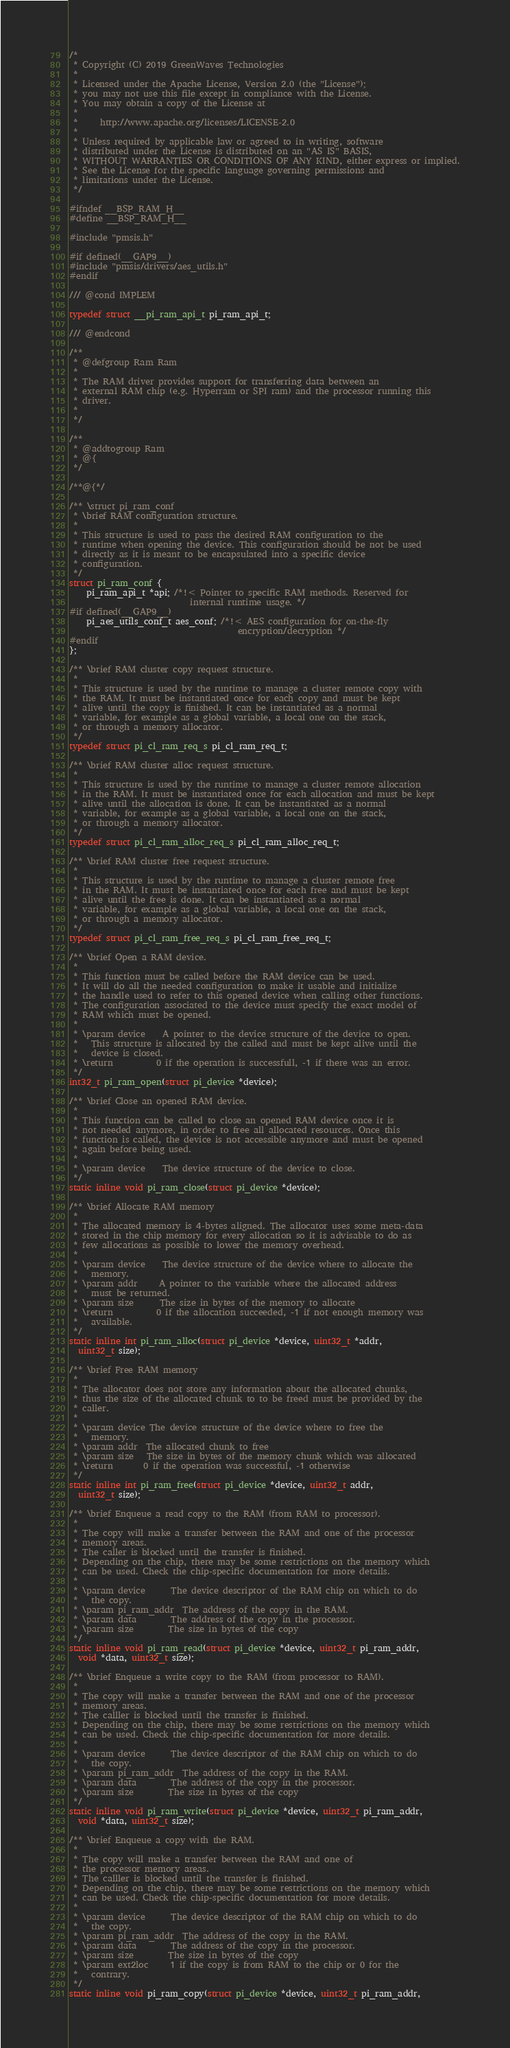<code> <loc_0><loc_0><loc_500><loc_500><_C_>/*
 * Copyright (C) 2019 GreenWaves Technologies
 *
 * Licensed under the Apache License, Version 2.0 (the "License");
 * you may not use this file except in compliance with the License.
 * You may obtain a copy of the License at
 *
 *     http://www.apache.org/licenses/LICENSE-2.0
 *
 * Unless required by applicable law or agreed to in writing, software
 * distributed under the License is distributed on an "AS IS" BASIS,
 * WITHOUT WARRANTIES OR CONDITIONS OF ANY KIND, either express or implied.
 * See the License for the specific language governing permissions and
 * limitations under the License.
 */

#ifndef __BSP_RAM_H__
#define __BSP_RAM_H__

#include "pmsis.h"

#if defined(__GAP9__)
#include "pmsis/drivers/aes_utils.h"
#endif

/// @cond IMPLEM

typedef struct __pi_ram_api_t pi_ram_api_t;

/// @endcond

/**
 * @defgroup Ram Ram
 *
 * The RAM driver provides support for transferring data between an
 * external RAM chip (e.g. Hyperram or SPI ram) and the processor running this
 * driver.
 *
 */

/**
 * @addtogroup Ram
 * @{
 */

/**@{*/

/** \struct pi_ram_conf
 * \brief RAM configuration structure.
 *
 * This structure is used to pass the desired RAM configuration to the
 * runtime when opening the device. This configuration should be not be used
 * directly as it is meant to be encapsulated into a specific device
 * configuration.
 */
struct pi_ram_conf {
    pi_ram_api_t *api; /*!< Pointer to specific RAM methods. Reserved for
                            internal runtime usage. */
#if defined(__GAP9__)
    pi_aes_utils_conf_t aes_conf; /*!< AES configuration for on-the-fly
                                       encryption/decryption */
#endif
};

/** \brief RAM cluster copy request structure.
 *
 * This structure is used by the runtime to manage a cluster remote copy with
 * the RAM. It must be instantiated once for each copy and must be kept
 * alive until the copy is finished. It can be instantiated as a normal
 * variable, for example as a global variable, a local one on the stack,
 * or through a memory allocator.
 */
typedef struct pi_cl_ram_req_s pi_cl_ram_req_t;

/** \brief RAM cluster alloc request structure.
 *
 * This structure is used by the runtime to manage a cluster remote allocation
 * in the RAM. It must be instantiated once for each allocation and must be kept
 * alive until the allocation is done. It can be instantiated as a normal
 * variable, for example as a global variable, a local one on the stack,
 * or through a memory allocator.
 */
typedef struct pi_cl_ram_alloc_req_s pi_cl_ram_alloc_req_t;

/** \brief RAM cluster free request structure.
 *
 * This structure is used by the runtime to manage a cluster remote free
 * in the RAM. It must be instantiated once for each free and must be kept
 * alive until the free is done. It can be instantiated as a normal
 * variable, for example as a global variable, a local one on the stack,
 * or through a memory allocator.
 */
typedef struct pi_cl_ram_free_req_s pi_cl_ram_free_req_t;

/** \brief Open a RAM device.
 *
 * This function must be called before the RAM device can be used.
 * It will do all the needed configuration to make it usable and initialize
 * the handle used to refer to this opened device when calling other functions.
 * The configuration associated to the device must specify the exact model of
 * RAM which must be opened.
 *
 * \param device    A pointer to the device structure of the device to open.
 *   This structure is allocated by the called and must be kept alive until the
 *   device is closed.
 * \return          0 if the operation is successfull, -1 if there was an error.
 */
int32_t pi_ram_open(struct pi_device *device);

/** \brief Close an opened RAM device.
 *
 * This function can be called to close an opened RAM device once it is
 * not needed anymore, in order to free all allocated resources. Once this
 * function is called, the device is not accessible anymore and must be opened
 * again before being used.
 *
 * \param device    The device structure of the device to close.
 */
static inline void pi_ram_close(struct pi_device *device);

/** \brief Allocate RAM memory
 *
 * The allocated memory is 4-bytes aligned. The allocator uses some meta-data
 * stored in the chip memory for every allocation so it is advisable to do as
 * few allocations as possible to lower the memory overhead.
 *
 * \param device    The device structure of the device where to allocate the
 *   memory.
 * \param addr     A pointer to the variable where the allocated address
 *   must be returned.
 * \param size      The size in bytes of the memory to allocate
 * \return          0 if the allocation succeeded, -1 if not enough memory was
 *   available.
 */
static inline int pi_ram_alloc(struct pi_device *device, uint32_t *addr,
  uint32_t size);

/** \brief Free RAM memory
 *
 * The allocator does not store any information about the allocated chunks,
 * thus the size of the allocated chunk to to be freed must be provided by the
 * caller.
 *
 * \param device The device structure of the device where to free the
 *   memory.
 * \param addr  The allocated chunk to free
 * \param size   The size in bytes of the memory chunk which was allocated
 * \return       0 if the operation was successful, -1 otherwise
 */
static inline int pi_ram_free(struct pi_device *device, uint32_t addr,
  uint32_t size);

/** \brief Enqueue a read copy to the RAM (from RAM to processor).
 *
 * The copy will make a transfer between the RAM and one of the processor
 * memory areas.
 * The caller is blocked until the transfer is finished.
 * Depending on the chip, there may be some restrictions on the memory which
 * can be used. Check the chip-specific documentation for more details.
 *
 * \param device      The device descriptor of the RAM chip on which to do
 *   the copy.
 * \param pi_ram_addr  The address of the copy in the RAM.
 * \param data        The address of the copy in the processor.
 * \param size        The size in bytes of the copy
 */
static inline void pi_ram_read(struct pi_device *device, uint32_t pi_ram_addr,
  void *data, uint32_t size);

/** \brief Enqueue a write copy to the RAM (from processor to RAM).
 *
 * The copy will make a transfer between the RAM and one of the processor
 * memory areas.
 * The calller is blocked until the transfer is finished.
 * Depending on the chip, there may be some restrictions on the memory which
 * can be used. Check the chip-specific documentation for more details.
 *
 * \param device      The device descriptor of the RAM chip on which to do
 *   the copy.
 * \param pi_ram_addr  The address of the copy in the RAM.
 * \param data        The address of the copy in the processor.
 * \param size        The size in bytes of the copy
 */
static inline void pi_ram_write(struct pi_device *device, uint32_t pi_ram_addr,
  void *data, uint32_t size);

/** \brief Enqueue a copy with the RAM.
 *
 * The copy will make a transfer between the RAM and one of
 * the processor memory areas.
 * The calller is blocked until the transfer is finished.
 * Depending on the chip, there may be some restrictions on the memory which
 * can be used. Check the chip-specific documentation for more details.
 *
 * \param device      The device descriptor of the RAM chip on which to do
 *   the copy.
 * \param pi_ram_addr  The address of the copy in the RAM.
 * \param data        The address of the copy in the processor.
 * \param size        The size in bytes of the copy
 * \param ext2loc     1 if the copy is from RAM to the chip or 0 for the
 *   contrary.
 */
static inline void pi_ram_copy(struct pi_device *device, uint32_t pi_ram_addr,</code> 